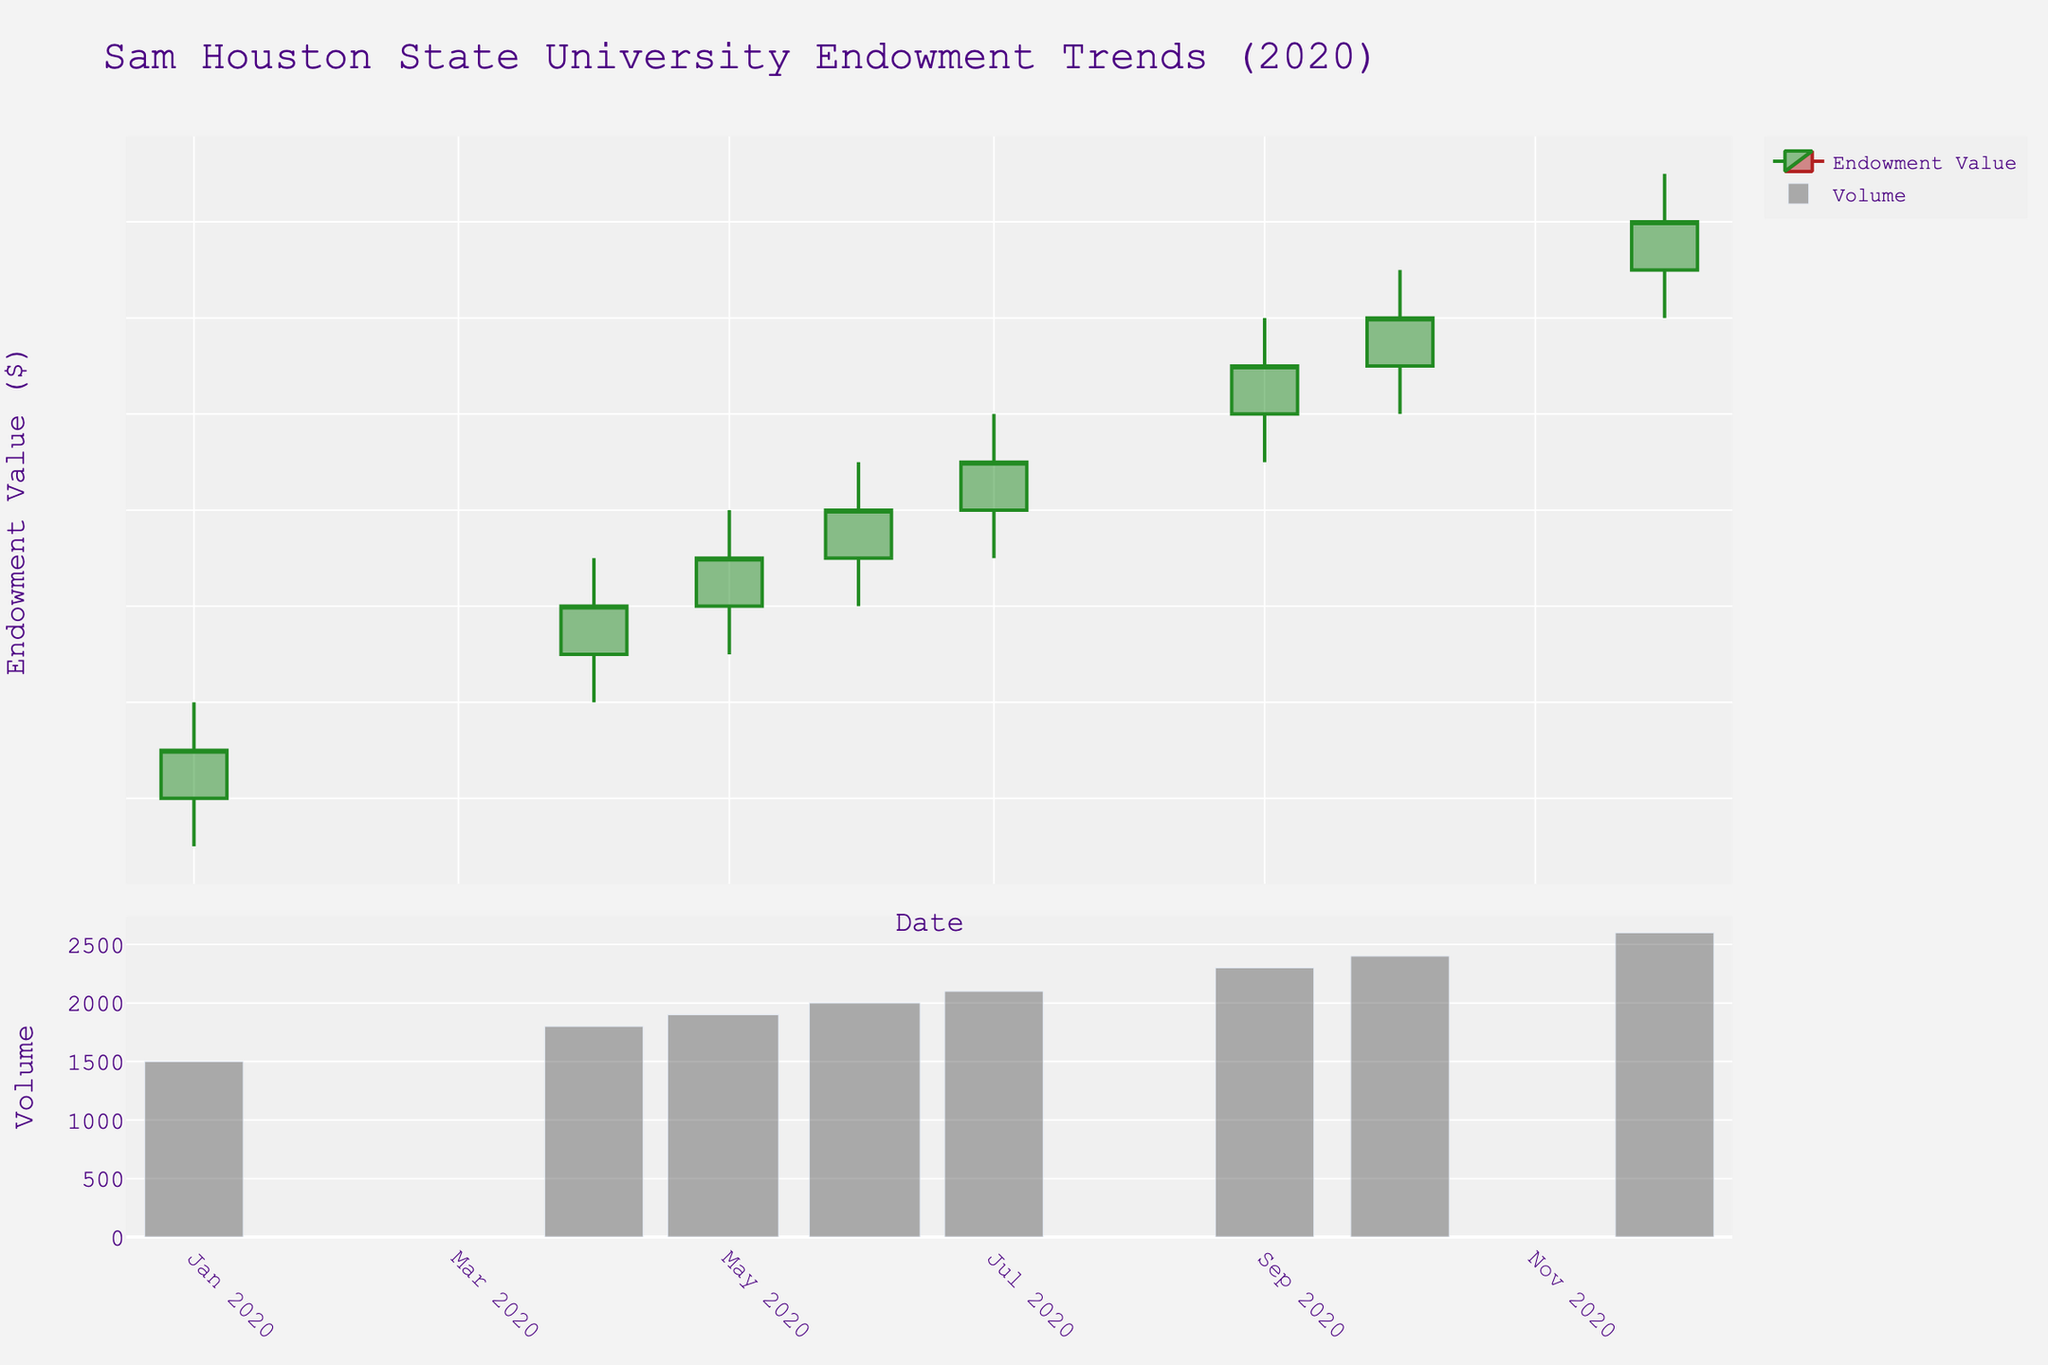What is the title of the plot? The title of the plot is displayed at the top center of the figure, and it reads: "Sam Houston State University Endowment Trends (2020)"
Answer: Sam Houston State University Endowment Trends (2020) How many months of data are represented in the plot? The x-axis of the plot displays a time series from January 2020 to December 2020, covering 12 months
Answer: 12 What was the highest endowment value in 2020 and in which month did it occur? The highest value is the peak of the upper wick of the candlestick and occurs in December 2020, where the high value reached $31,500,000
Answer: $31,500,000 in December Which month saw the highest trading volume in 2020? The bar chart on the second subplot shows the trading volume by height, and the tallest bar is in December 2020
Answer: December Did the endowment value ever decrease from one month to the next in 2020? By looking at the closing values month-over-month, there is no candlestick indicating a decrease; all closing values are higher than the preceding month's closing values
Answer: No What was the opening endowment value in January 2020 and the closing value in December 2020? The opening value in January is at the top of the green candlestick for January, and the closing value in December is at the bottom of the green candlestick for December
Answer: $25,000,000 and $31,000,000 By how much did the endowment value increase from January to December 2020? The increase is the difference between the closing value in December and the opening value in January, which is $31,000,000 - $25,000,000
Answer: $6,000,000 Which month had the smallest difference between the high and low endowment values? The difference between high and low values can be observed by the height of the candlestick from top wick to bottom wick. May 2020 has the smallest difference with a narrow range between $28,000,000 to $26,500,000
Answer: May Does the candlestick plot show a general upward or downward trend over 2020? The overall trend can be determined by observing the arrangement of candlesticks and noticing that closing values consistently rise throughout the year
Answer: Upward How many green (increasing) candlesticks are there in the plot? The green candlesticks represent months where the closing value is higher than the opening value. Each month shows a consistent increase, therefore all 12 months have green candlesticks
Answer: 12 